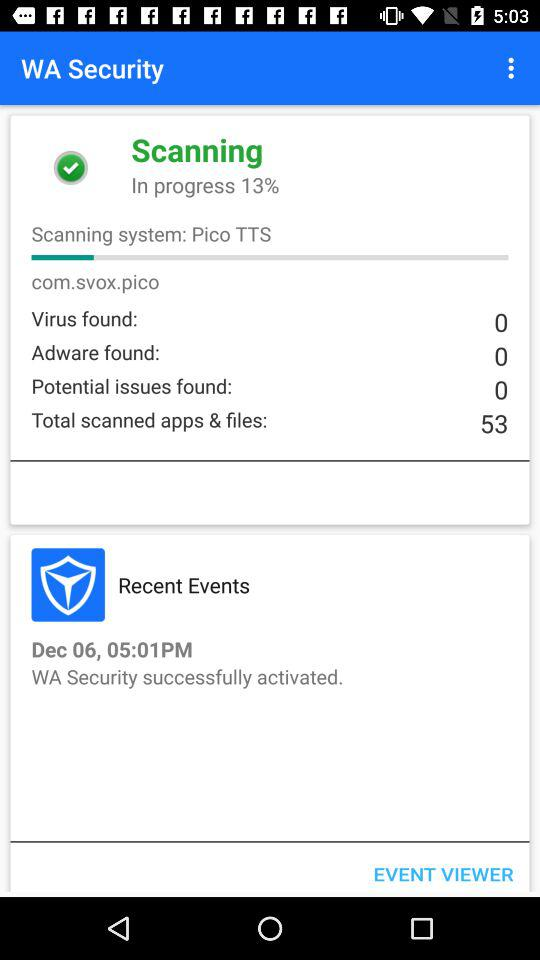How many "Adware" are found? There are 0 adware found. 